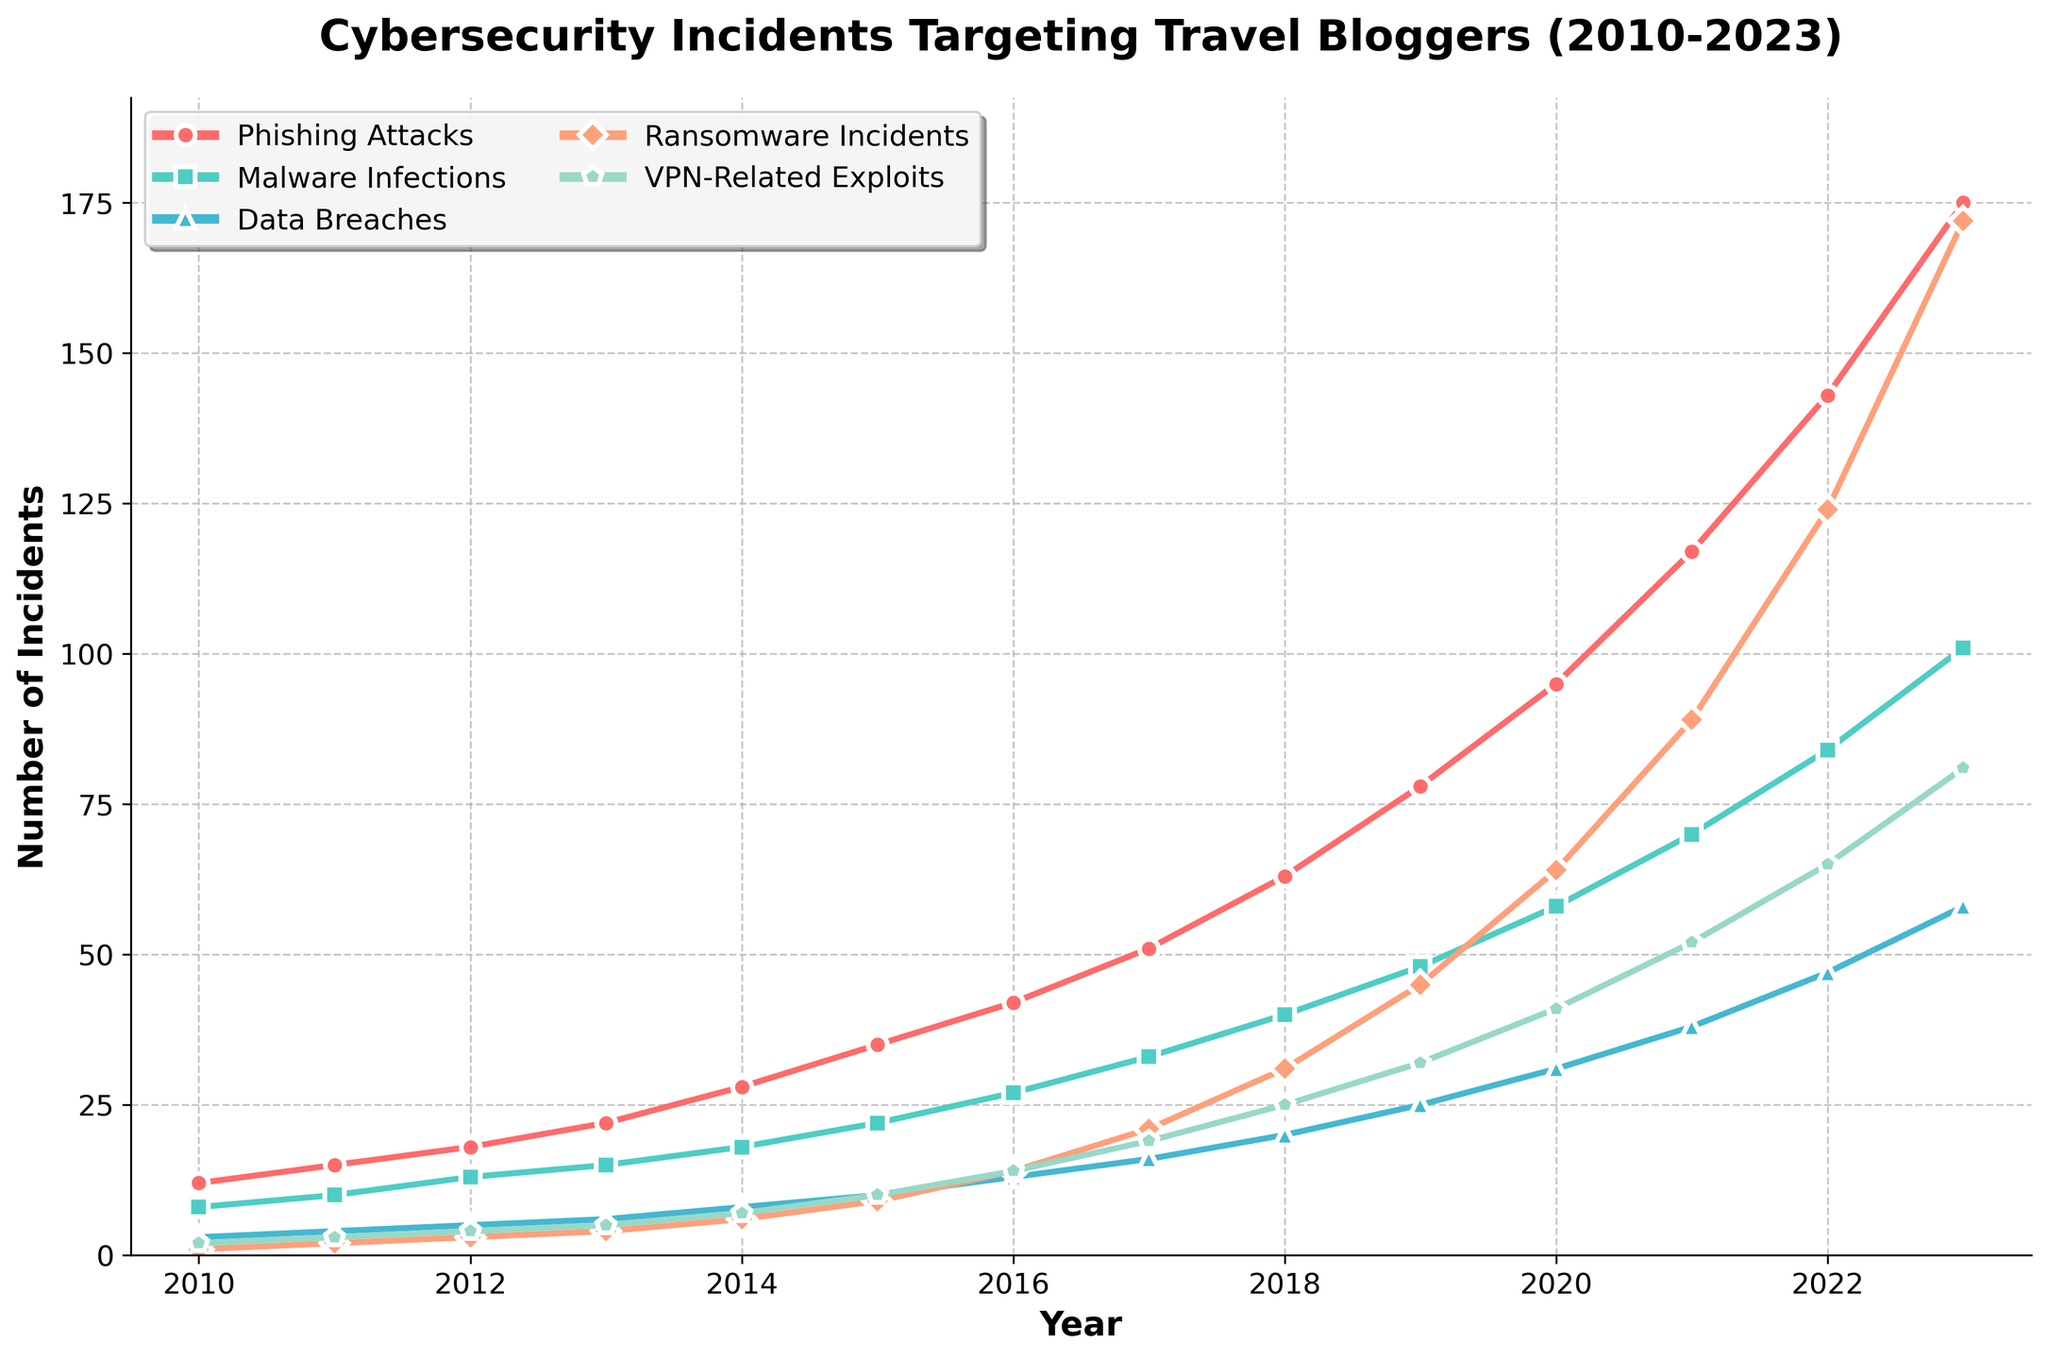What is the trend of phishing attacks from 2010 to 2023? To determine the trend of phishing attacks, observe the line corresponding to phishing attacks (represented by red circles). The number of phishing attacks increases consistently every year from 2010 to 2023.
Answer: Increasing How many ransomware incidents occurred in total from 2010 to 2015? Sum the number of ransomware incidents for each year from 2010 to 2015: 1 (2010) + 2 (2011) + 3 (2012) + 4 (2013) + 6 (2014) + 9 (2015) = 25.
Answer: 25 Which year saw the highest number of VPN-related exploits? Identify the peak point for VPN-related exploits (represented by the green line with pentagon markers). The highest point is in 2023.
Answer: 2023 Is there a year when ransomware incidents outnumbered phishing attacks? Compare the number of ransomware incidents with phishing attacks each year. In all years, the number of phishing attacks is higher than ransomware incidents.
Answer: No How do malware infections in 2017 compare to those in 2014? Find the data points for malware infections in 2014 and 2017. In 2014, there were 18 malware infections, whereas in 2017, there were 33. Thus, 33 is greater than 18.
Answer: 2017 had more Which category saw the greatest increase in incidents from 2020 to 2023? Calculate the difference for each category between 2020 and 2023. Phishing Attacks: 175 - 95 = 80, Malware Infections: 101 - 58 = 43, Data Breaches: 58 - 31 = 27, Ransomware Incidents: 172 - 64 = 108, VPN-Related Exploits: 81 - 41 = 40. The greatest increase is in Ransomware Incidents (108).
Answer: Ransomware Incidents What is the average number of data breaches per year over the period 2010-2023? Sum the number of data breaches from 2010 to 2023 and divide by the number of years (14). (3 + 4 + 5 + 6 + 8 + 10 + 13 + 16 + 20 + 25 + 31 + 38 + 47 + 58) / 14 = 21.21 (approximately).
Answer: 21.21 How does the growth rate of phishing attacks compare with that of ransomware incidents over the entire period? Calculate the overall growth for both from 2010 to 2023: Phishing Attacks: 175 - 12 = 163, Ransomware Incidents: 172 - 1 = 171. While both categories show significant growth, ransomware incidents show a slightly higher increase.
Answer: Ransomware growth is higher Which year had the smallest number of total incidents across all categories? Sum incidents for each year and compare to find the smallest total. For 2010: 26; for 2011: 34; for 2012: 43; for 2013: 52; for 2014: 67; for 2015: 86; for 2016: 110; for 2017: 140; for 2018: 179; for 2019: 228; for 2020: 289; for 2021: 366; for 2022: 463; for 2023: 587. The smallest is in 2010.
Answer: 2010 